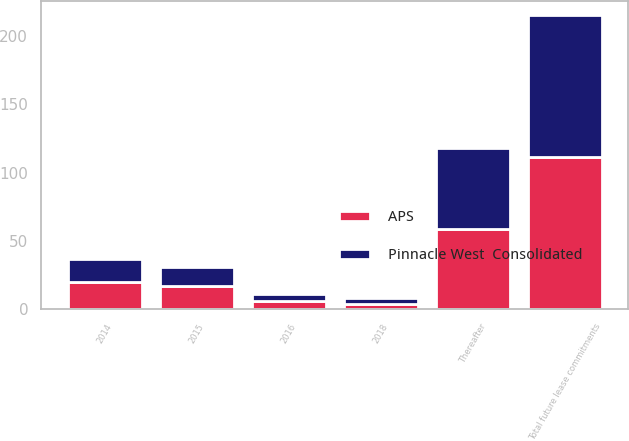Convert chart. <chart><loc_0><loc_0><loc_500><loc_500><stacked_bar_chart><ecel><fcel>2014<fcel>2015<fcel>2016<fcel>2018<fcel>Thereafter<fcel>Total future lease commitments<nl><fcel>APS<fcel>20<fcel>17<fcel>6<fcel>4<fcel>59<fcel>111<nl><fcel>Pinnacle West  Consolidated<fcel>17<fcel>14<fcel>5<fcel>4<fcel>59<fcel>104<nl></chart> 